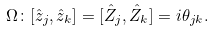Convert formula to latex. <formula><loc_0><loc_0><loc_500><loc_500>\Omega \colon [ \hat { z } _ { j } , \hat { z } _ { k } ] = [ \hat { Z } _ { j } , \hat { Z } _ { k } ] = i \theta _ { j k } .</formula> 